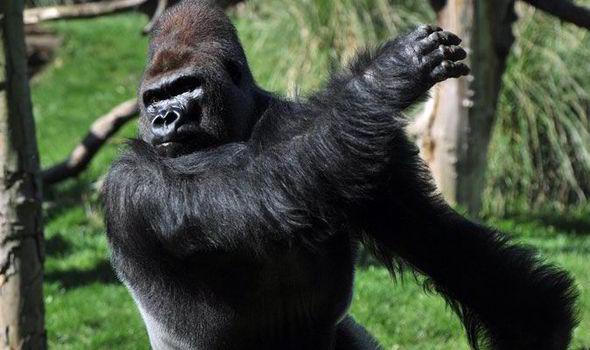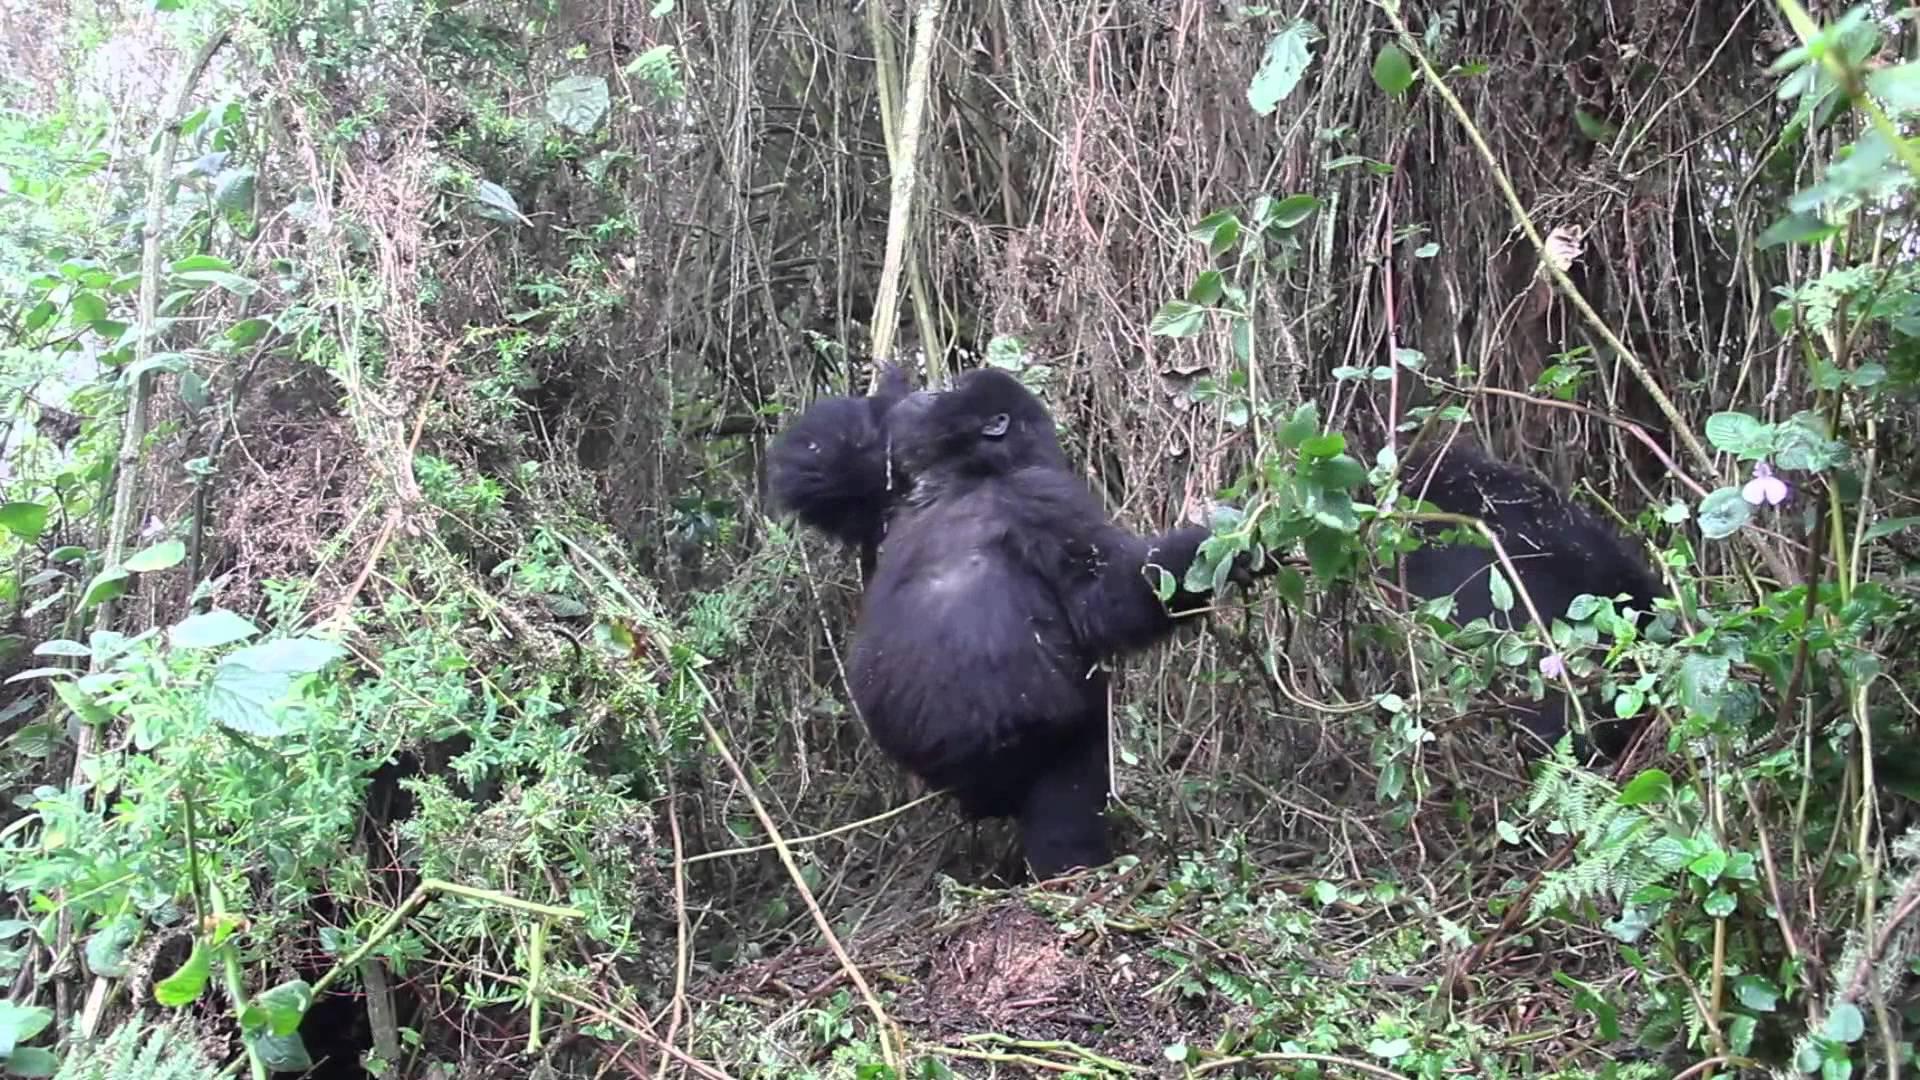The first image is the image on the left, the second image is the image on the right. Evaluate the accuracy of this statement regarding the images: "Each image contains just one ape, and each ape is hanging from a branch-like growth.". Is it true? Answer yes or no. No. The first image is the image on the left, the second image is the image on the right. Given the left and right images, does the statement "At least one ape is on the ground." hold true? Answer yes or no. Yes. 